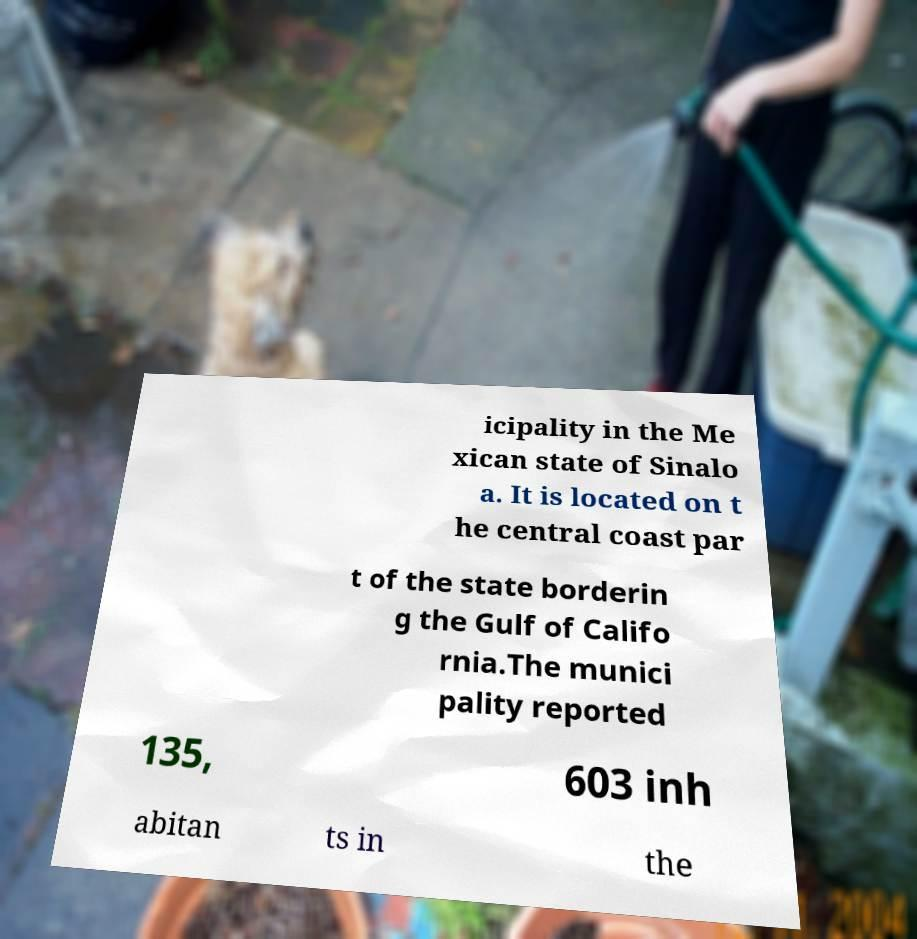Can you read and provide the text displayed in the image?This photo seems to have some interesting text. Can you extract and type it out for me? icipality in the Me xican state of Sinalo a. It is located on t he central coast par t of the state borderin g the Gulf of Califo rnia.The munici pality reported 135, 603 inh abitan ts in the 